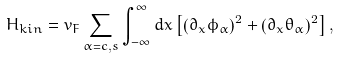<formula> <loc_0><loc_0><loc_500><loc_500>H _ { k i n } = v _ { F } \sum _ { \alpha = c , s } \int ^ { \infty } _ { - \infty } d x \left [ \left ( \partial _ { x } \phi _ { \alpha } \right ) ^ { 2 } + \left ( \partial _ { x } \theta _ { \alpha } \right ) ^ { 2 } \right ] ,</formula> 